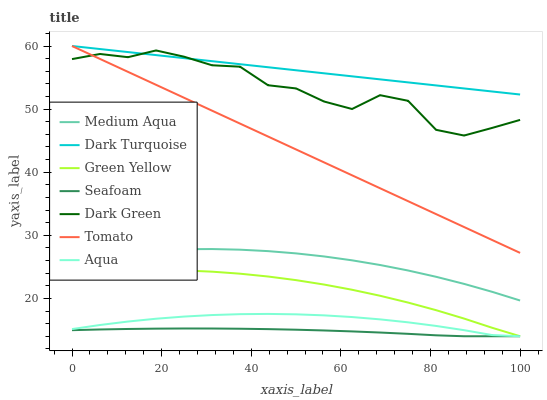Does Seafoam have the minimum area under the curve?
Answer yes or no. Yes. Does Dark Turquoise have the maximum area under the curve?
Answer yes or no. Yes. Does Aqua have the minimum area under the curve?
Answer yes or no. No. Does Aqua have the maximum area under the curve?
Answer yes or no. No. Is Tomato the smoothest?
Answer yes or no. Yes. Is Dark Green the roughest?
Answer yes or no. Yes. Is Dark Turquoise the smoothest?
Answer yes or no. No. Is Dark Turquoise the roughest?
Answer yes or no. No. Does Dark Turquoise have the lowest value?
Answer yes or no. No. Does Aqua have the highest value?
Answer yes or no. No. Is Seafoam less than Tomato?
Answer yes or no. Yes. Is Tomato greater than Seafoam?
Answer yes or no. Yes. Does Seafoam intersect Tomato?
Answer yes or no. No. 